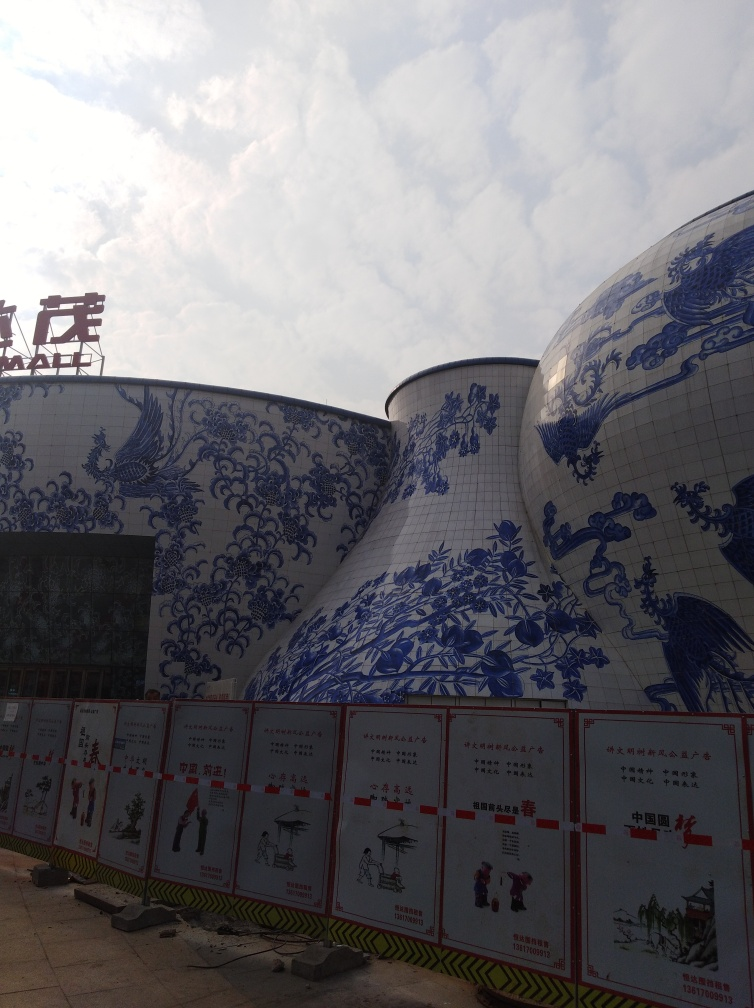What do the signs in front of the buildings convey? The signs feature illustrations and Chinese text, which suggests they could be informational, providing guidance or conveying rules to visitors. Unfortunately, without a translation, it is difficult to specify the exact message, but their formal presentation indicates they are important for people visiting the site. Could the signs be related to safety instructions or regulations? That is a possibility. Safety instructions or regulations are often displayed in a clear and formal manner, much like these signs. Depending on the nature of the site, such as if it were a factory or a place where fragile exhibits are displayed, conveying safety information would be crucial. 